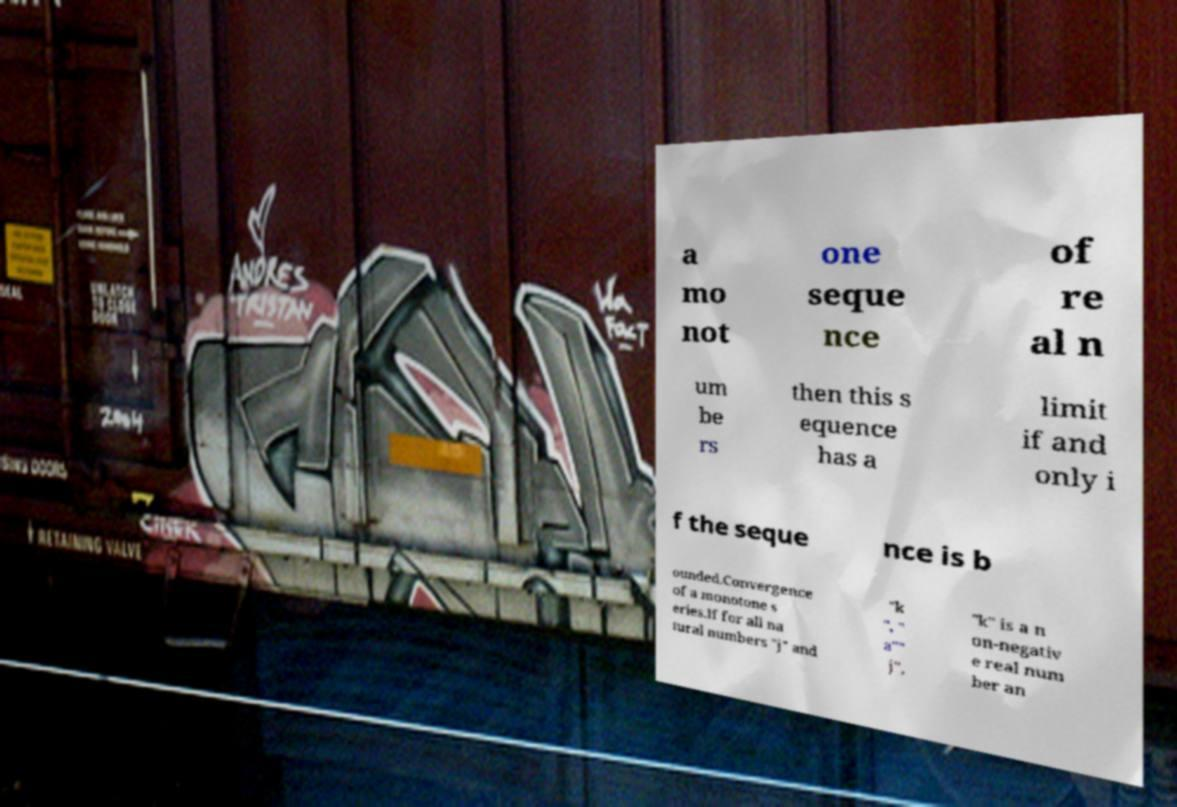What messages or text are displayed in this image? I need them in a readable, typed format. a mo not one seque nce of re al n um be rs then this s equence has a limit if and only i f the seque nce is b ounded.Convergence of a monotone s eries.If for all na tural numbers "j" and "k ", " a"" j", "k" is a n on-negativ e real num ber an 